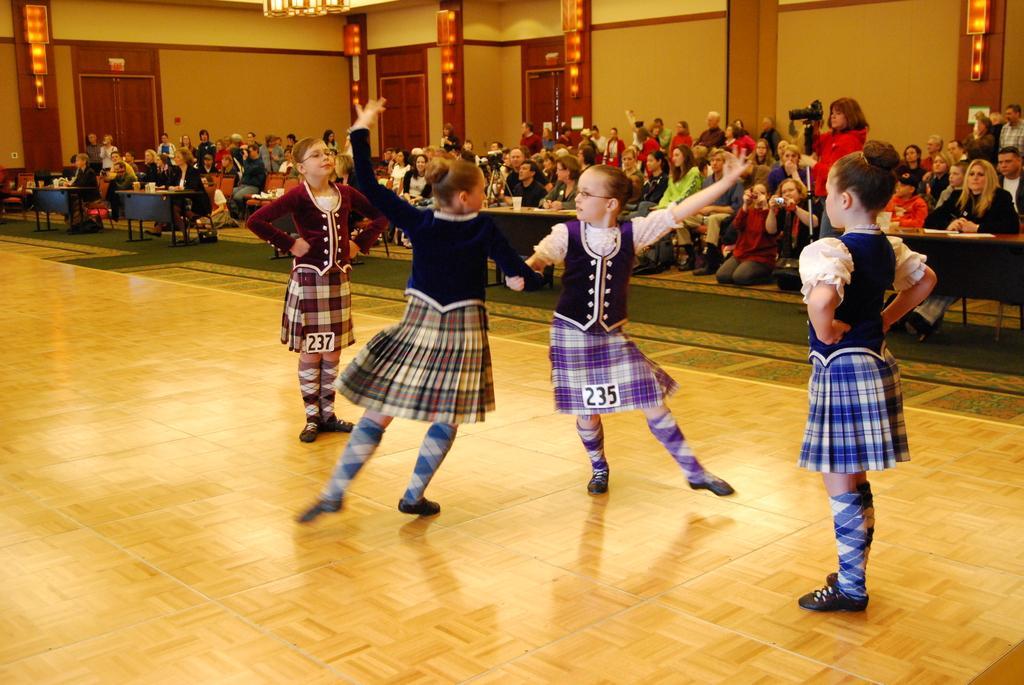Please provide a concise description of this image. In this image, we can see girls dancing on the floor. In the background, we can see the people, tables, wall, doors, lights and few objects. Few people are holding some objects. 